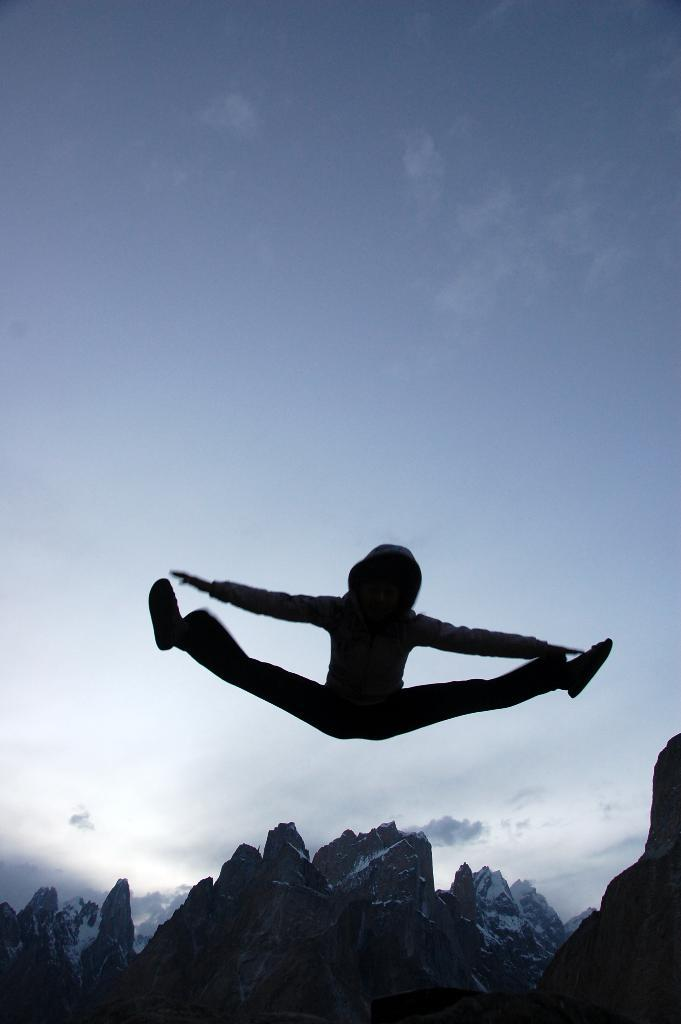What is happening to the person in the image? The person is in the air in the image. What can be seen in the distance behind the person? There are mountains visible in the background of the image. What colors are present in the sky in the image? The sky is blue and white in color. Where is the person's brother in the image? There is no mention of a brother in the image, so it cannot be determined where they might be. 